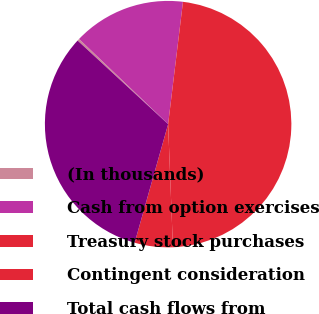<chart> <loc_0><loc_0><loc_500><loc_500><pie_chart><fcel>(In thousands)<fcel>Cash from option exercises<fcel>Treasury stock purchases<fcel>Contingent consideration<fcel>Total cash flows from<nl><fcel>0.28%<fcel>14.78%<fcel>47.46%<fcel>5.0%<fcel>32.49%<nl></chart> 